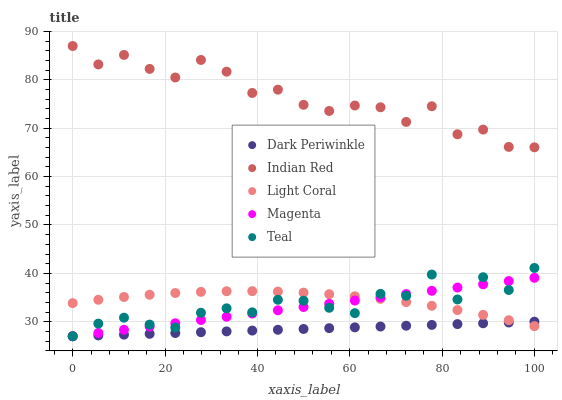Does Dark Periwinkle have the minimum area under the curve?
Answer yes or no. Yes. Does Indian Red have the maximum area under the curve?
Answer yes or no. Yes. Does Magenta have the minimum area under the curve?
Answer yes or no. No. Does Magenta have the maximum area under the curve?
Answer yes or no. No. Is Dark Periwinkle the smoothest?
Answer yes or no. Yes. Is Indian Red the roughest?
Answer yes or no. Yes. Is Magenta the smoothest?
Answer yes or no. No. Is Magenta the roughest?
Answer yes or no. No. Does Magenta have the lowest value?
Answer yes or no. Yes. Does Indian Red have the lowest value?
Answer yes or no. No. Does Indian Red have the highest value?
Answer yes or no. Yes. Does Magenta have the highest value?
Answer yes or no. No. Is Light Coral less than Indian Red?
Answer yes or no. Yes. Is Indian Red greater than Light Coral?
Answer yes or no. Yes. Does Dark Periwinkle intersect Magenta?
Answer yes or no. Yes. Is Dark Periwinkle less than Magenta?
Answer yes or no. No. Is Dark Periwinkle greater than Magenta?
Answer yes or no. No. Does Light Coral intersect Indian Red?
Answer yes or no. No. 